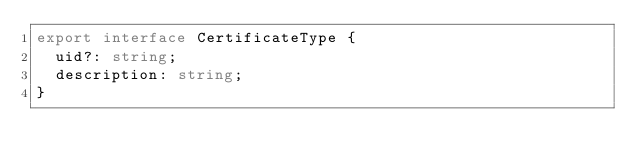<code> <loc_0><loc_0><loc_500><loc_500><_TypeScript_>export interface CertificateType {
  uid?: string;
  description: string;
}
</code> 